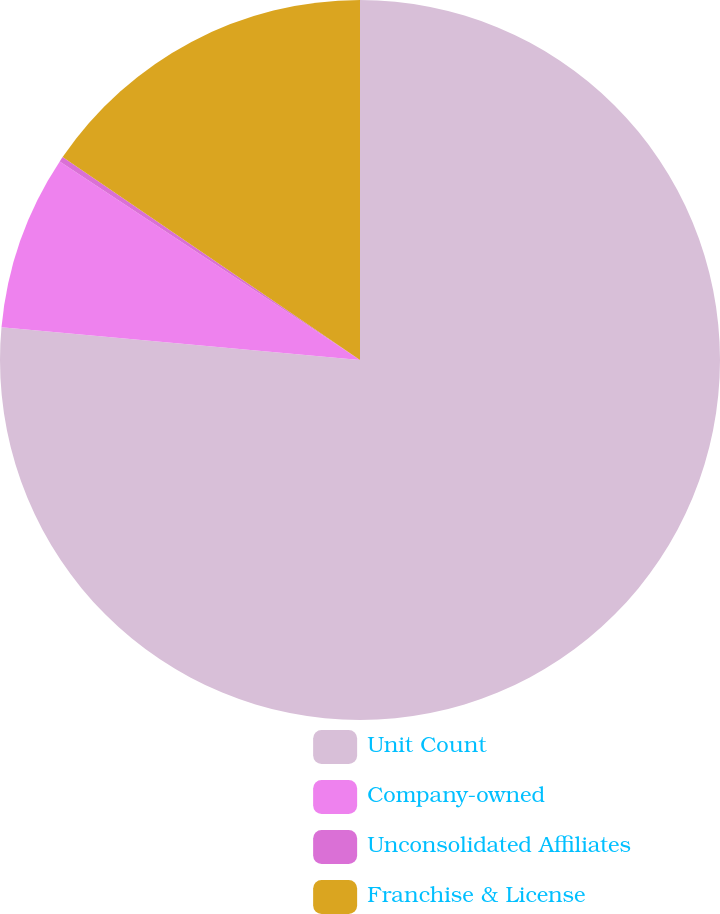Convert chart. <chart><loc_0><loc_0><loc_500><loc_500><pie_chart><fcel>Unit Count<fcel>Company-owned<fcel>Unconsolidated Affiliates<fcel>Franchise & License<nl><fcel>76.45%<fcel>7.85%<fcel>0.23%<fcel>15.47%<nl></chart> 